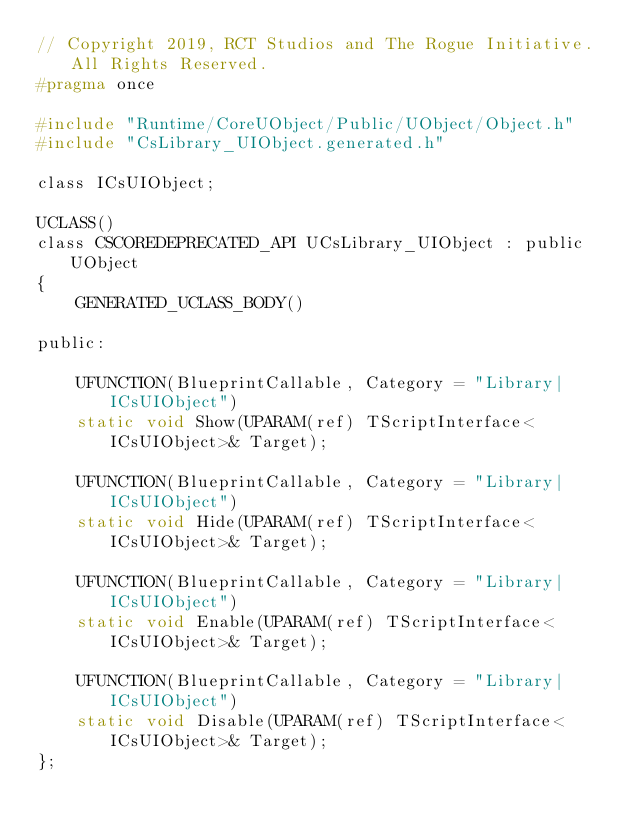<code> <loc_0><loc_0><loc_500><loc_500><_C_>// Copyright 2019, RCT Studios and The Rogue Initiative. All Rights Reserved.
#pragma once

#include "Runtime/CoreUObject/Public/UObject/Object.h"
#include "CsLibrary_UIObject.generated.h"

class ICsUIObject;

UCLASS()
class CSCOREDEPRECATED_API UCsLibrary_UIObject : public UObject
{
	GENERATED_UCLASS_BODY()

public:

	UFUNCTION(BlueprintCallable, Category = "Library|ICsUIObject")
	static void Show(UPARAM(ref) TScriptInterface<ICsUIObject>& Target);

	UFUNCTION(BlueprintCallable, Category = "Library|ICsUIObject")
	static void Hide(UPARAM(ref) TScriptInterface<ICsUIObject>& Target);

	UFUNCTION(BlueprintCallable, Category = "Library|ICsUIObject")
	static void Enable(UPARAM(ref) TScriptInterface<ICsUIObject>& Target);

	UFUNCTION(BlueprintCallable, Category = "Library|ICsUIObject")
	static void Disable(UPARAM(ref) TScriptInterface<ICsUIObject>& Target);
};</code> 